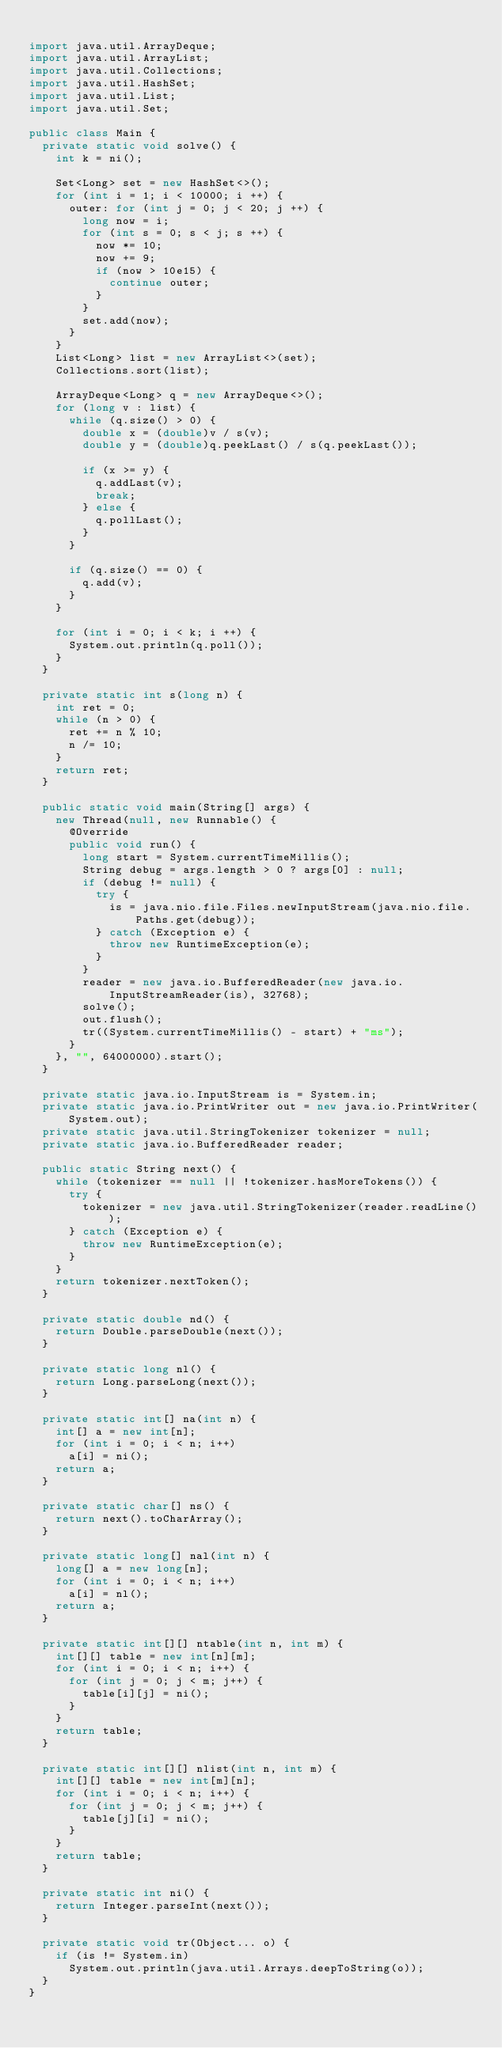Convert code to text. <code><loc_0><loc_0><loc_500><loc_500><_Java_>
import java.util.ArrayDeque;
import java.util.ArrayList;
import java.util.Collections;
import java.util.HashSet;
import java.util.List;
import java.util.Set;

public class Main {
  private static void solve() {
    int k = ni();

    Set<Long> set = new HashSet<>();
    for (int i = 1; i < 10000; i ++) {
      outer: for (int j = 0; j < 20; j ++) {
        long now = i;
        for (int s = 0; s < j; s ++) {
          now *= 10;
          now += 9;
          if (now > 10e15) {
            continue outer;
          }
        }
        set.add(now);
      }
    }
    List<Long> list = new ArrayList<>(set);
    Collections.sort(list);
    
    ArrayDeque<Long> q = new ArrayDeque<>();
    for (long v : list) {
      while (q.size() > 0) {
        double x = (double)v / s(v);
        double y = (double)q.peekLast() / s(q.peekLast());
        
        if (x >= y) {
          q.addLast(v);
          break;
        } else {
          q.pollLast();
        }
      }

      if (q.size() == 0) {
        q.add(v);
      }
    }
    
    for (int i = 0; i < k; i ++) {
      System.out.println(q.poll());
    }
  }

  private static int s(long n) {
    int ret = 0;
    while (n > 0) {
      ret += n % 10;
      n /= 10;
    }
    return ret;
  }

  public static void main(String[] args) {
    new Thread(null, new Runnable() {
      @Override
      public void run() {
        long start = System.currentTimeMillis();
        String debug = args.length > 0 ? args[0] : null;
        if (debug != null) {
          try {
            is = java.nio.file.Files.newInputStream(java.nio.file.Paths.get(debug));
          } catch (Exception e) {
            throw new RuntimeException(e);
          }
        }
        reader = new java.io.BufferedReader(new java.io.InputStreamReader(is), 32768);
        solve();
        out.flush();
        tr((System.currentTimeMillis() - start) + "ms");
      }
    }, "", 64000000).start();
  }

  private static java.io.InputStream is = System.in;
  private static java.io.PrintWriter out = new java.io.PrintWriter(System.out);
  private static java.util.StringTokenizer tokenizer = null;
  private static java.io.BufferedReader reader;

  public static String next() {
    while (tokenizer == null || !tokenizer.hasMoreTokens()) {
      try {
        tokenizer = new java.util.StringTokenizer(reader.readLine());
      } catch (Exception e) {
        throw new RuntimeException(e);
      }
    }
    return tokenizer.nextToken();
  }

  private static double nd() {
    return Double.parseDouble(next());
  }

  private static long nl() {
    return Long.parseLong(next());
  }

  private static int[] na(int n) {
    int[] a = new int[n];
    for (int i = 0; i < n; i++)
      a[i] = ni();
    return a;
  }

  private static char[] ns() {
    return next().toCharArray();
  }

  private static long[] nal(int n) {
    long[] a = new long[n];
    for (int i = 0; i < n; i++)
      a[i] = nl();
    return a;
  }

  private static int[][] ntable(int n, int m) {
    int[][] table = new int[n][m];
    for (int i = 0; i < n; i++) {
      for (int j = 0; j < m; j++) {
        table[i][j] = ni();
      }
    }
    return table;
  }

  private static int[][] nlist(int n, int m) {
    int[][] table = new int[m][n];
    for (int i = 0; i < n; i++) {
      for (int j = 0; j < m; j++) {
        table[j][i] = ni();
      }
    }
    return table;
  }

  private static int ni() {
    return Integer.parseInt(next());
  }

  private static void tr(Object... o) {
    if (is != System.in)
      System.out.println(java.util.Arrays.deepToString(o));
  }
}


</code> 